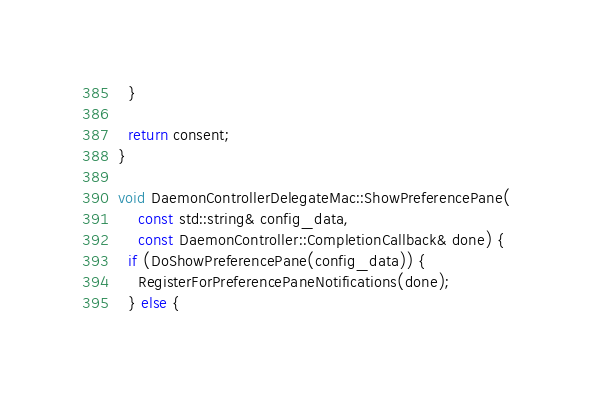<code> <loc_0><loc_0><loc_500><loc_500><_ObjectiveC_>  }

  return consent;
}

void DaemonControllerDelegateMac::ShowPreferencePane(
    const std::string& config_data,
    const DaemonController::CompletionCallback& done) {
  if (DoShowPreferencePane(config_data)) {
    RegisterForPreferencePaneNotifications(done);
  } else {</code> 